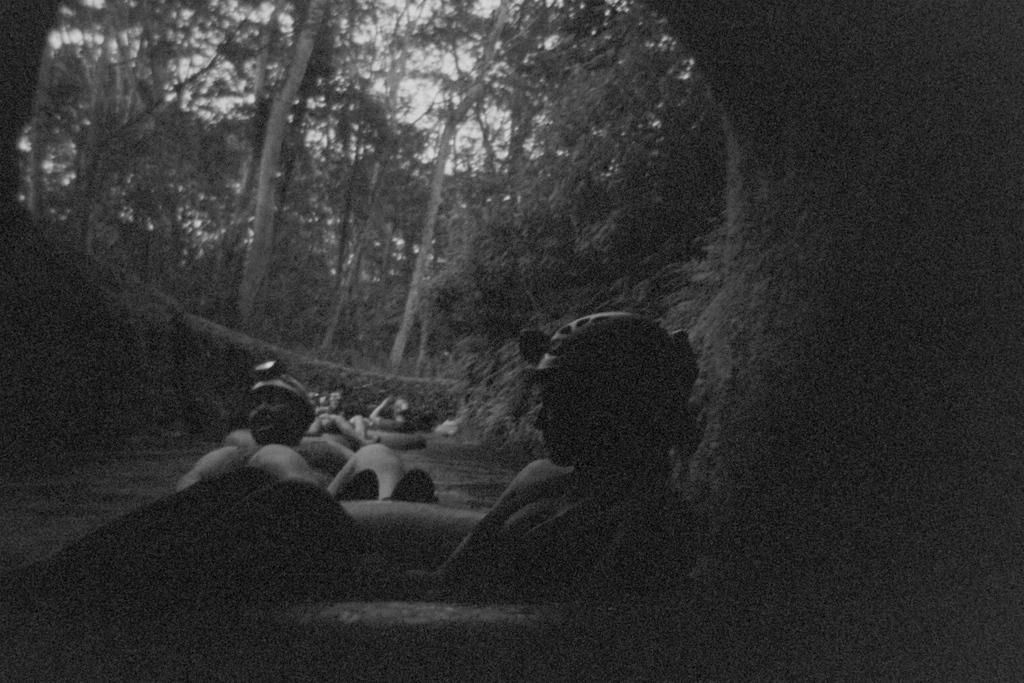What is the color scheme of the image? The image is black and white. What are the people in the image doing? The people are floating on the water surface. What can be seen in the background of the image? There are tall trees visible behind the people. How many ducks are swimming in the water during the rainstorm in the image? There is no rainstorm or ducks present in the image; it is a black and white image of people floating on the water surface with tall trees in the background. 